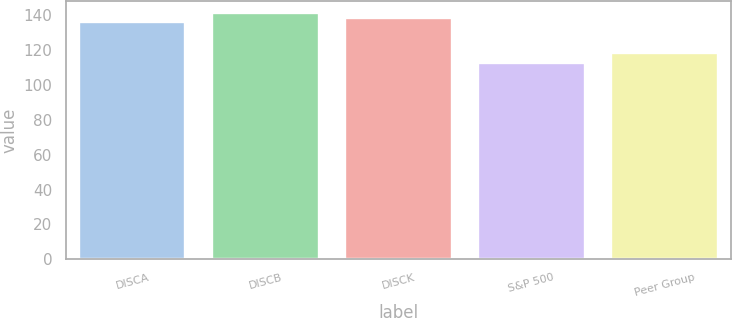<chart> <loc_0><loc_0><loc_500><loc_500><bar_chart><fcel>DISCA<fcel>DISCB<fcel>DISCK<fcel>S&P 500<fcel>Peer Group<nl><fcel>135.96<fcel>141.16<fcel>138.56<fcel>112.78<fcel>118.4<nl></chart> 